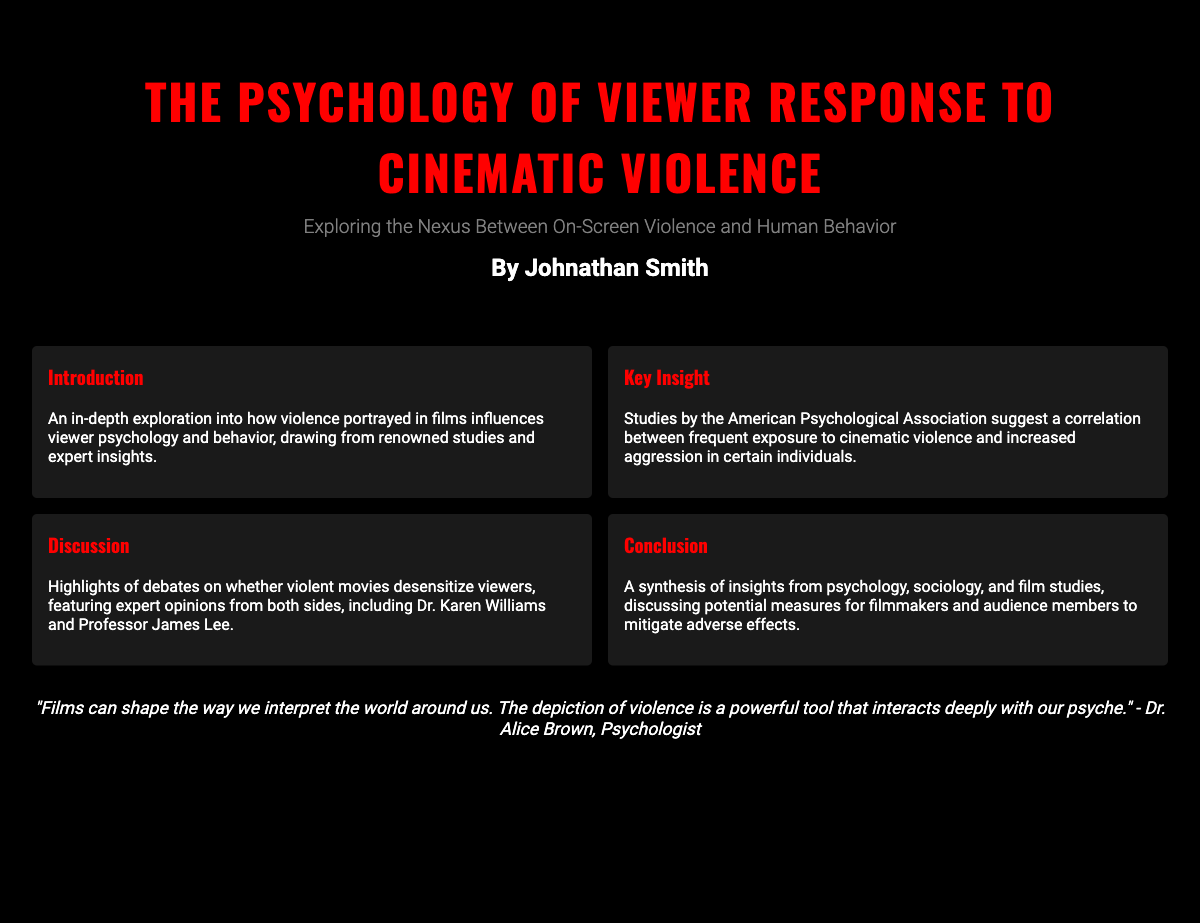What is the title of the book? The title of the book is presented prominently on the cover.
Answer: The Psychology of Viewer Response to Cinematic Violence Who is the author of the book? The author's name is listed under the title on the cover.
Answer: Johnathan Smith What is the main focus of the book? The subtitle provides insight into the central theme of the book.
Answer: Exploring the Nexus Between On-Screen Violence and Human Behavior What does the American Psychological Association suggest? The key insight mentions findings from the American Psychological Association regarding cinematic violence.
Answer: A correlation between frequent exposure to cinematic violence and increased aggression Who are two experts mentioned in the discussion? The discussion section highlights expert opinions from two individuals.
Answer: Dr. Karen Williams and Professor James Lee What is a notable quote from the book? A quote from Dr. Alice Brown is featured prominently in the design.
Answer: "Films can shape the way we interpret the world around us." What does the expert endorsement state? The endorsement section provides an opinion from an expert about the book.
Answer: A thorough examination of the intricate relationship between screen violence and observer behavior What is one potential measure discussed in the conclusion? The conclusion synthesizes insights suggesting different ways to approach the impact of cinematic violence.
Answer: Mitigate adverse effects 